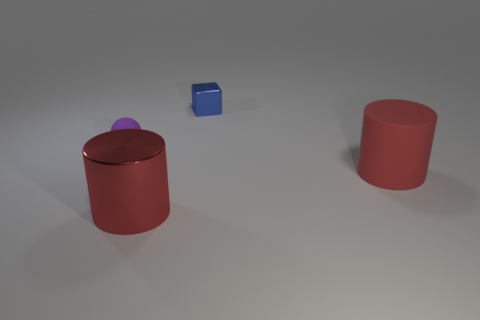How many other things are there of the same color as the rubber cylinder?
Provide a short and direct response. 1. What shape is the big matte object that is the same color as the big metal object?
Your response must be concise. Cylinder. Does the small object behind the rubber ball have the same material as the small purple thing?
Offer a terse response. No. There is a large object that is to the left of the object that is behind the purple rubber object; what is its material?
Your answer should be compact. Metal. There is a metallic thing in front of the large cylinder that is behind the cylinder that is on the left side of the tiny blue block; what size is it?
Provide a short and direct response. Large. What number of purple objects are either metal spheres or tiny rubber balls?
Your response must be concise. 1. Is the shape of the object behind the tiny purple rubber ball the same as  the large red metal thing?
Offer a very short reply. No. Is the number of small purple rubber balls on the right side of the tiny ball greater than the number of red objects?
Offer a very short reply. No. How many blue cubes have the same size as the rubber cylinder?
Offer a terse response. 0. What is the size of the other cylinder that is the same color as the metal cylinder?
Keep it short and to the point. Large. 